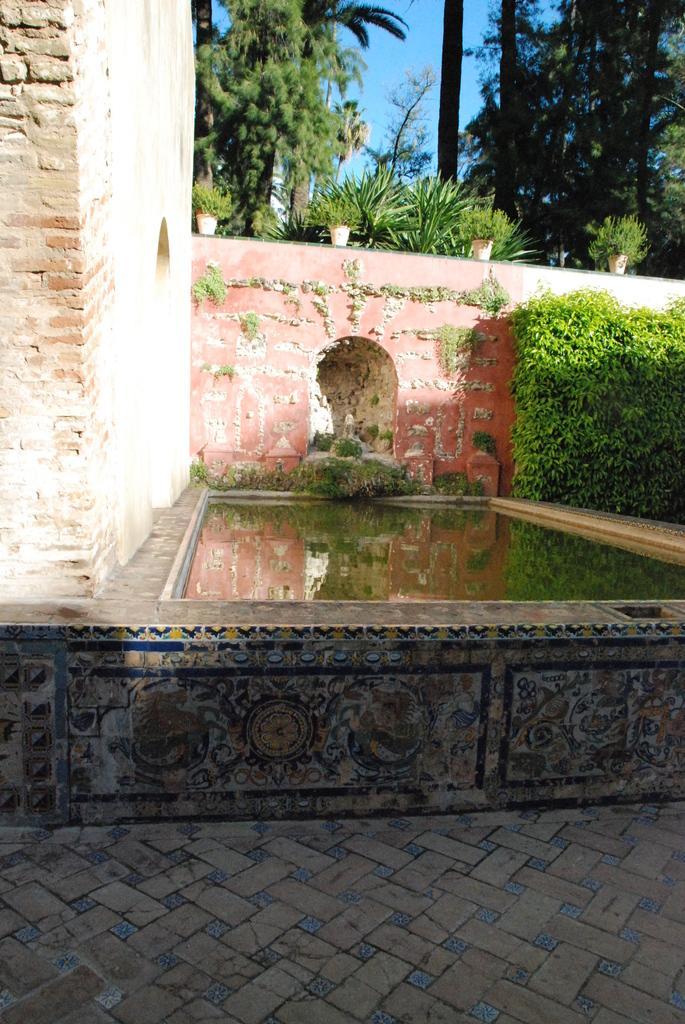How would you summarize this image in a sentence or two? This is water. Here we can see a wall and plants. In the background there are trees and sky. 